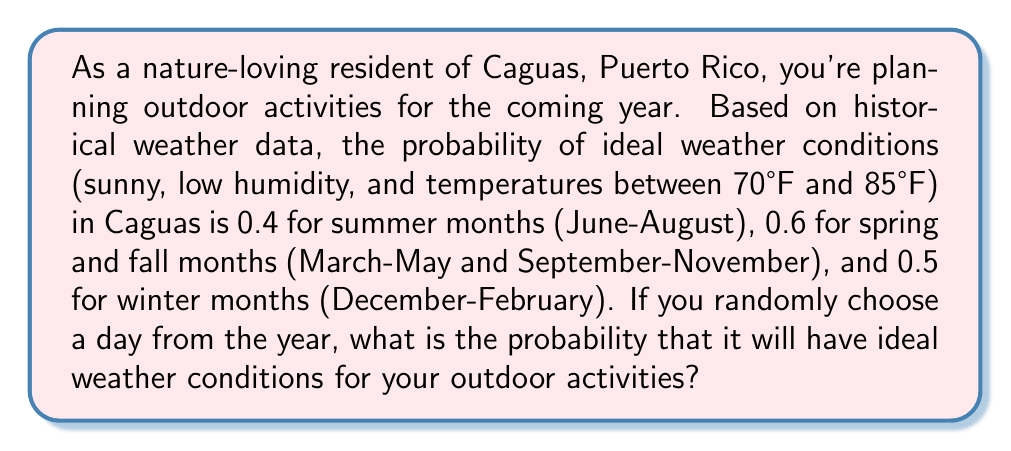Give your solution to this math problem. To solve this problem, we need to use the concept of total probability. Let's break it down step-by-step:

1) First, let's define our events:
   A: The day has ideal weather conditions
   S: The day is in summer
   SF: The day is in spring or fall
   W: The day is in winter

2) We're given the following probabilities:
   $P(A|S) = 0.4$
   $P(A|SF) = 0.6$
   $P(A|W) = 0.5$

3) We need to calculate the probabilities of a randomly chosen day being in each season:
   $P(S) = \frac{3}{12} = 0.25$ (3 months out of 12)
   $P(SF) = \frac{6}{12} = 0.5$ (6 months out of 12)
   $P(W) = \frac{3}{12} = 0.25$ (3 months out of 12)

4) Now we can use the law of total probability:
   $$P(A) = P(A|S)P(S) + P(A|SF)P(SF) + P(A|W)P(W)$$

5) Substituting the values:
   $$P(A) = (0.4)(0.25) + (0.6)(0.5) + (0.5)(0.25)$$

6) Calculating:
   $$P(A) = 0.1 + 0.3 + 0.125 = 0.525$$

Therefore, the probability of a randomly chosen day having ideal weather conditions is 0.525 or 52.5%.
Answer: $0.525$ or $52.5\%$ 